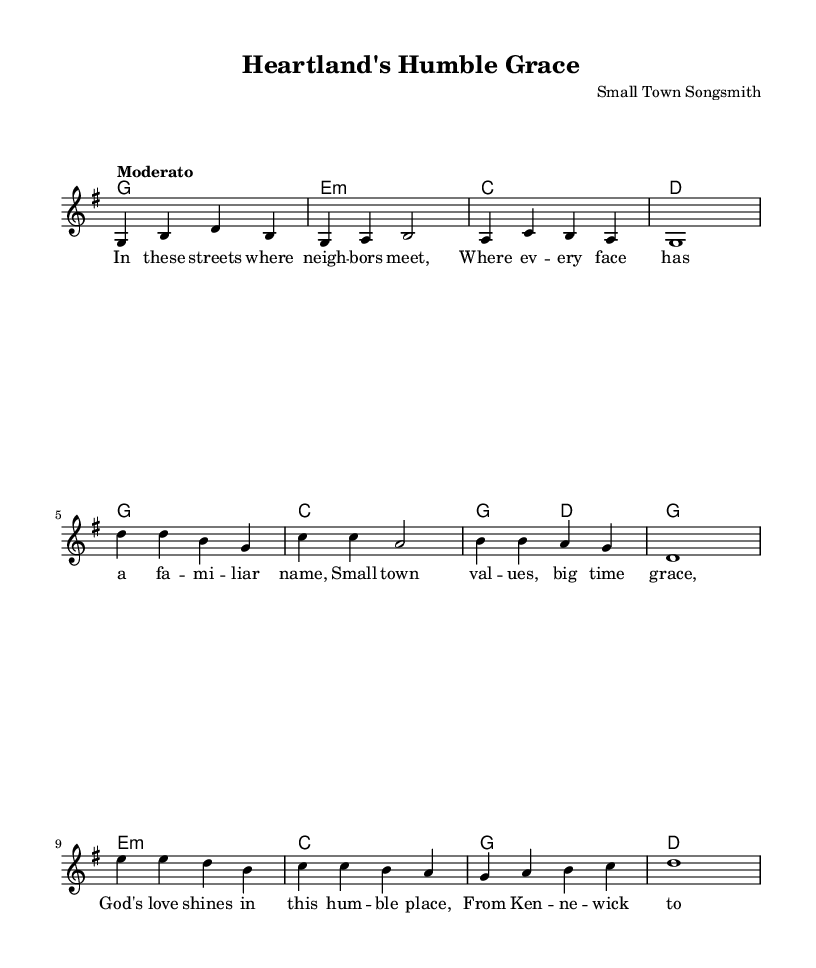What is the key signature of this music? The key signature is indicated in the global section, where it states "\key g \major", meaning the piece is in G major, which has one sharp (F#).
Answer: G major What is the time signature of this music? The time signature can be found in the global section as well, noted by "\time 4/4", which signifies that there are four beats in each measure.
Answer: 4/4 What is the tempo marking of this music? The tempo is mentioned in the global section, where it states "\tempo 'Moderato'", indicating a moderately paced tempo.
Answer: Moderato How many measures are in the verse? The verse section is made up of four lines, and accounting each line as a measure shows there are 4 measures total in the verse.
Answer: 4 Which part of the music contains the "small town values" theme? The phrase "Small town values" is located in the chorus, as indicated by its lyrics in the chorusWords section.
Answer: Chorus What does the bridge reflect about the community? The bridge lyrics discuss "roots" and "faith", underscoring a deep connection and strong belief in the community, which is typical of gospel hymns.
Answer: Community connection What are the primary chords used in the harmonies section? The harmony section starts with the G major chord and transitions through e minor, C major, and D major, showing a typical progression used in gospel music.
Answer: G, e minor, C, D 